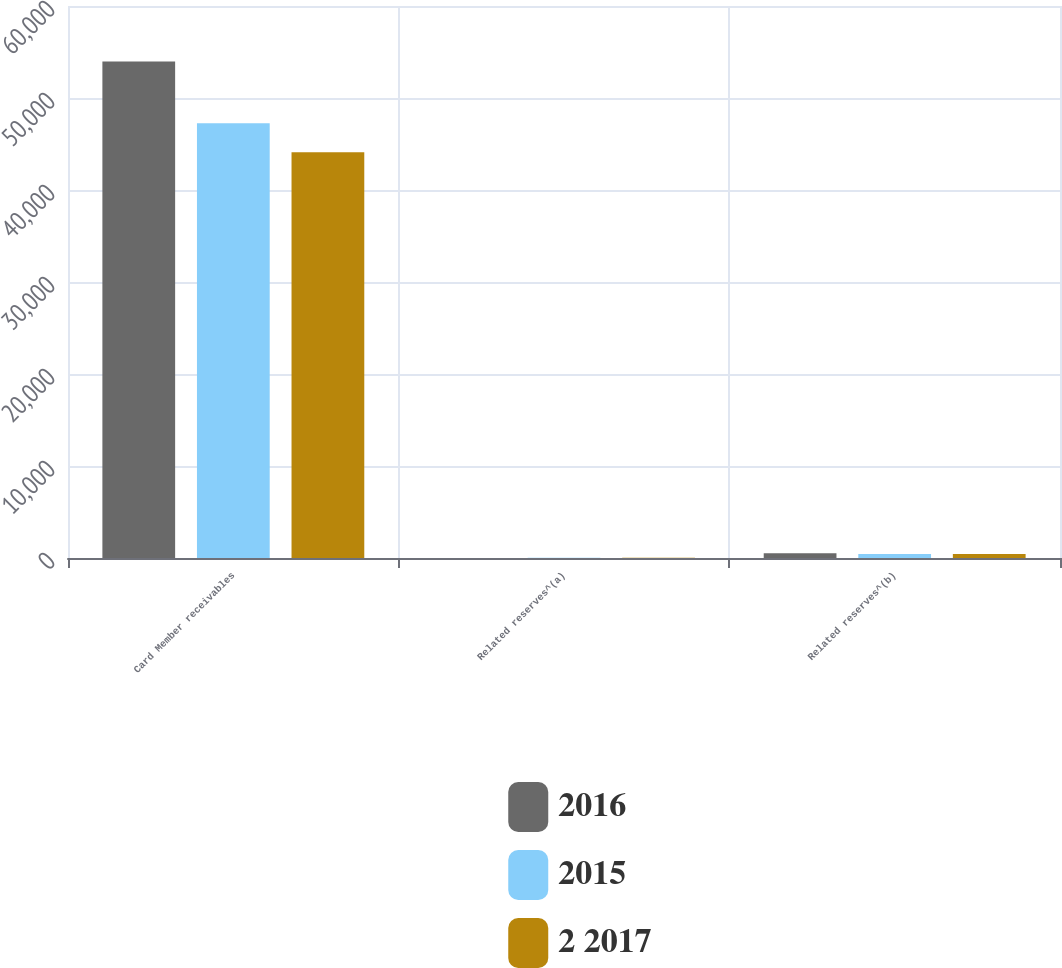Convert chart to OTSL. <chart><loc_0><loc_0><loc_500><loc_500><stacked_bar_chart><ecel><fcel>Card Member receivables<fcel>Related reserves^(a)<fcel>Related reserves^(b)<nl><fcel>2016<fcel>53967<fcel>3<fcel>518<nl><fcel>2015<fcel>47253<fcel>28<fcel>439<nl><fcel>2 2017<fcel>44100<fcel>20<fcel>442<nl></chart> 